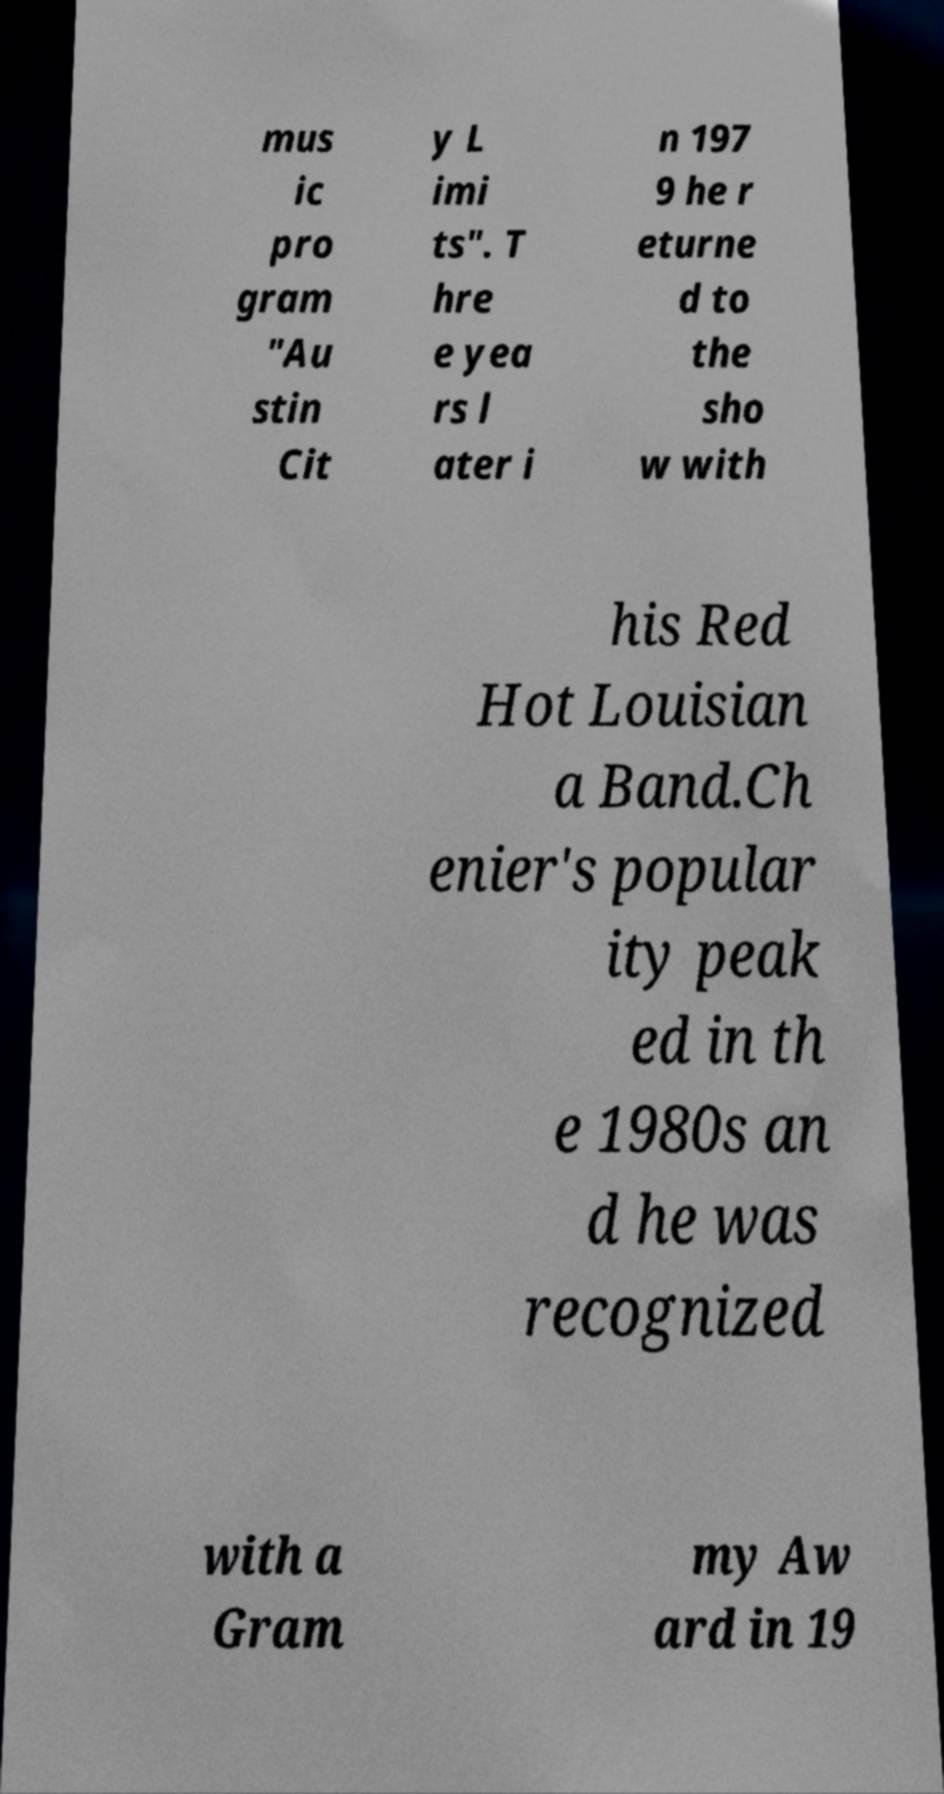Could you extract and type out the text from this image? mus ic pro gram "Au stin Cit y L imi ts". T hre e yea rs l ater i n 197 9 he r eturne d to the sho w with his Red Hot Louisian a Band.Ch enier's popular ity peak ed in th e 1980s an d he was recognized with a Gram my Aw ard in 19 